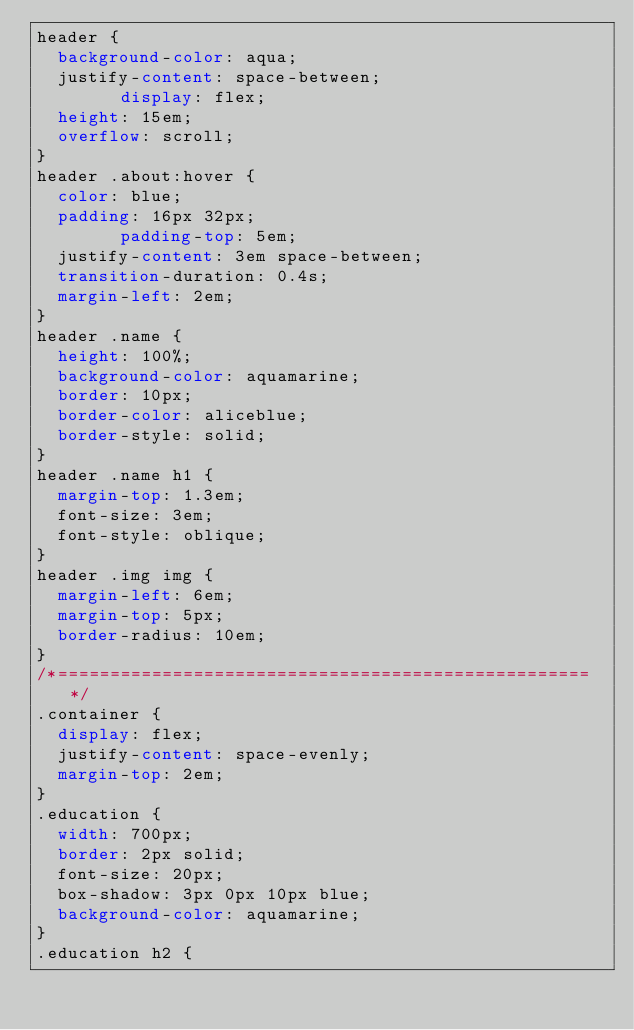<code> <loc_0><loc_0><loc_500><loc_500><_CSS_>header {
	background-color: aqua;
	justify-content: space-between;
        display: flex;
	height: 15em;
	overflow: scroll;
}
header .about:hover {
	color: blue;
	padding: 16px 32px;
        padding-top: 5em;
	justify-content: 3em space-between;
	transition-duration: 0.4s;
	margin-left: 2em;
}
header .name {
	height: 100%;
	background-color: aquamarine;
	border: 10px;
	border-color: aliceblue;
	border-style: solid;
}
header .name h1 {
	margin-top: 1.3em;
	font-size: 3em;
	font-style: oblique;
}
header .img img {
	margin-left: 6em;
	margin-top: 5px;
	border-radius: 10em;
}
/*===================================================*/
.container {
	display: flex;
	justify-content: space-evenly;
	margin-top: 2em;
}
.education {
	width: 700px;
	border: 2px solid;
	font-size: 20px;
	box-shadow: 3px 0px 10px blue;
	background-color: aquamarine;
}
.education h2 {</code> 